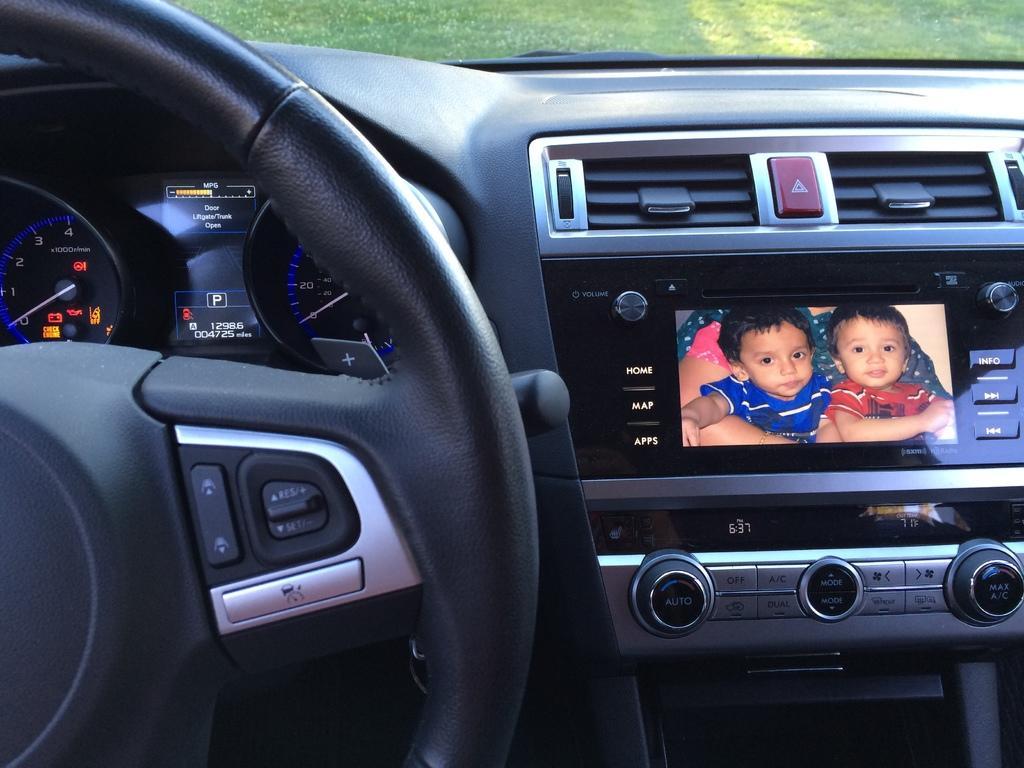Could you give a brief overview of what you see in this image? This is an inside image of the vehicle, in the vehicle, we can see the meters, steering and a music player, also we can see the grass. 